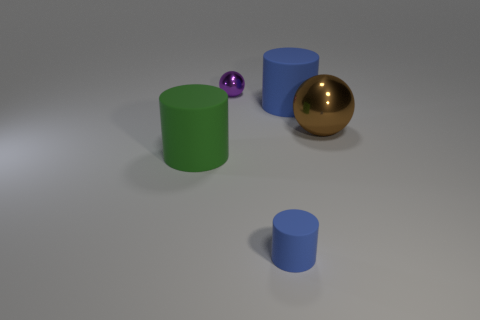How many cylinders are the same size as the purple metallic object?
Make the answer very short. 1. What shape is the large matte object that is the same color as the small rubber object?
Give a very brief answer. Cylinder. How many things are matte things that are left of the tiny purple thing or large green matte things?
Your response must be concise. 1. Is the number of small purple shiny things less than the number of small cyan objects?
Offer a very short reply. No. There is a brown thing that is the same material as the tiny purple object; what is its shape?
Ensure brevity in your answer.  Sphere. Are there any large blue rubber things on the right side of the tiny purple thing?
Your answer should be very brief. Yes. Is the number of green matte objects right of the large blue thing less than the number of cyan metallic cubes?
Give a very brief answer. No. What material is the big green object?
Your answer should be compact. Rubber. What color is the small metallic thing?
Give a very brief answer. Purple. What is the color of the rubber cylinder that is both behind the tiny matte object and to the right of the small purple shiny sphere?
Keep it short and to the point. Blue. 